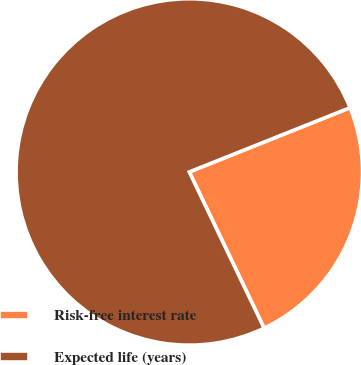Convert chart to OTSL. <chart><loc_0><loc_0><loc_500><loc_500><pie_chart><fcel>Risk-free interest rate<fcel>Expected life (years)<nl><fcel>23.94%<fcel>76.06%<nl></chart> 